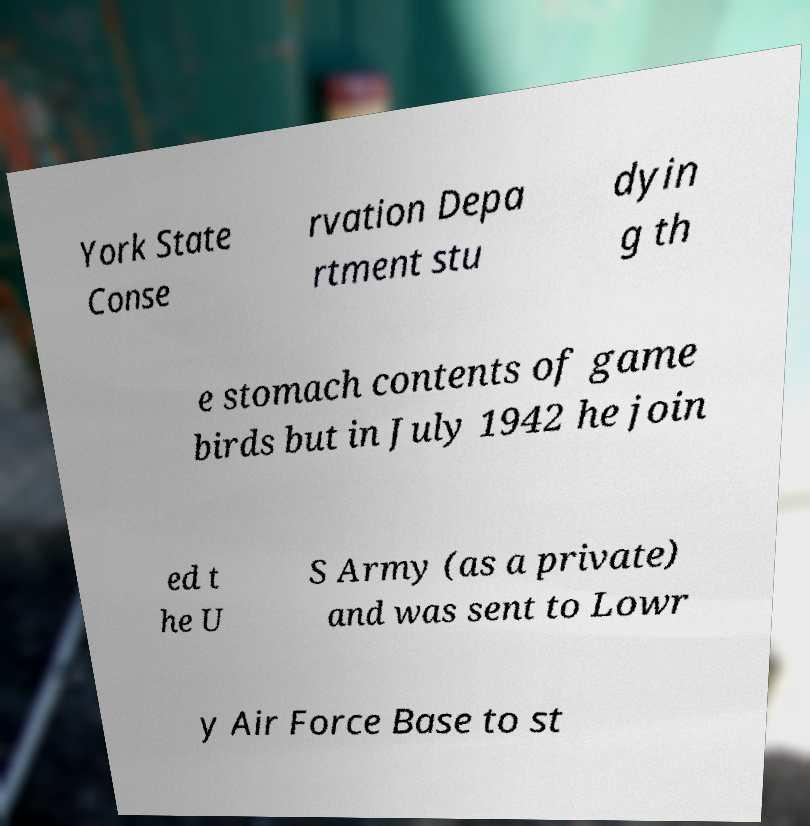I need the written content from this picture converted into text. Can you do that? York State Conse rvation Depa rtment stu dyin g th e stomach contents of game birds but in July 1942 he join ed t he U S Army (as a private) and was sent to Lowr y Air Force Base to st 